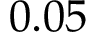Convert formula to latex. <formula><loc_0><loc_0><loc_500><loc_500>0 . 0 5</formula> 